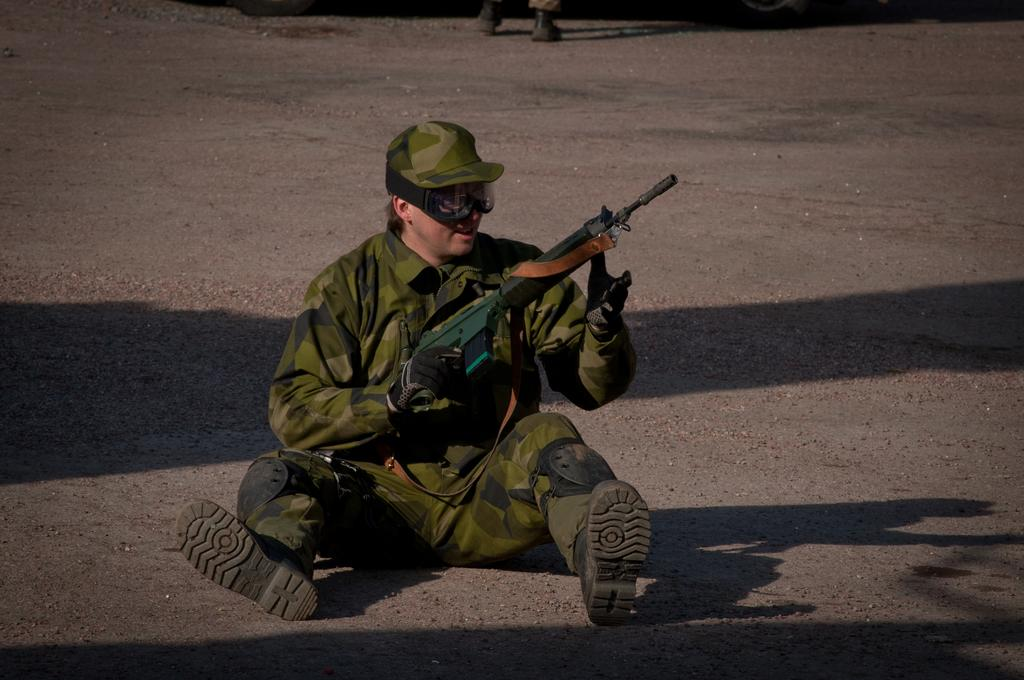What is the main subject of the image? There is a person in the image. What is the person doing in the image? The person is sitting on a road. What protective gear is the person wearing? The person is wearing gloves, goggles, and a cap. What object is the person holding? The person is holding a gun. What type of news can be heard coming from the radio in the image? There is no radio present in the image, so it's not possible to determine what news might be heard. How is the person tying a knot with the gun in the image? There is no knot or any indication of tying in the image; the person is simply holding a gun. 